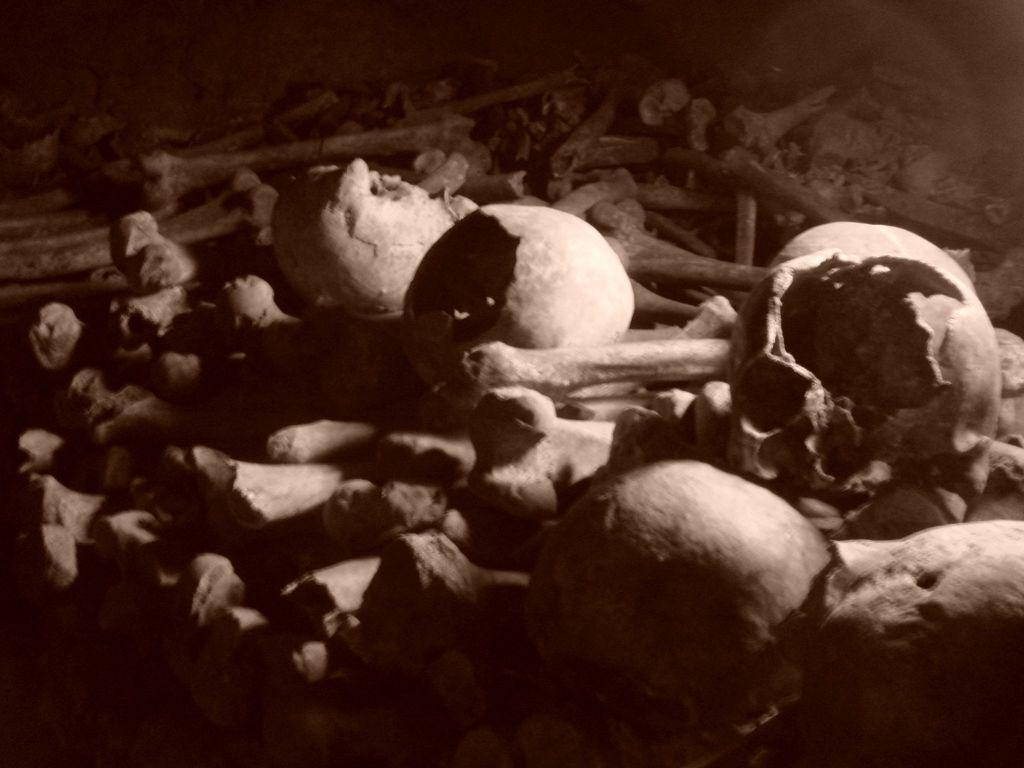What type of objects can be seen in the image? There are skulls and bones in the image. Where are the skulls and bones located? The skulls and bones are on the land. How many chairs are visible in the image? There are no chairs present in the image. What type of furniture can be seen in the image? There is no furniture present in the image. 